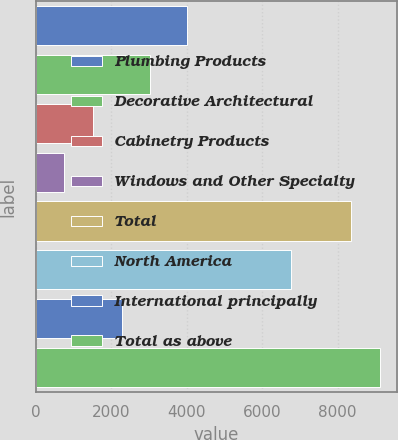Convert chart to OTSL. <chart><loc_0><loc_0><loc_500><loc_500><bar_chart><fcel>Plumbing Products<fcel>Decorative Architectural<fcel>Cabinetry Products<fcel>Windows and Other Specialty<fcel>Total<fcel>North America<fcel>International principally<fcel>Total as above<nl><fcel>3998<fcel>3036.2<fcel>1515.4<fcel>755<fcel>8359<fcel>6763<fcel>2275.8<fcel>9119.4<nl></chart> 